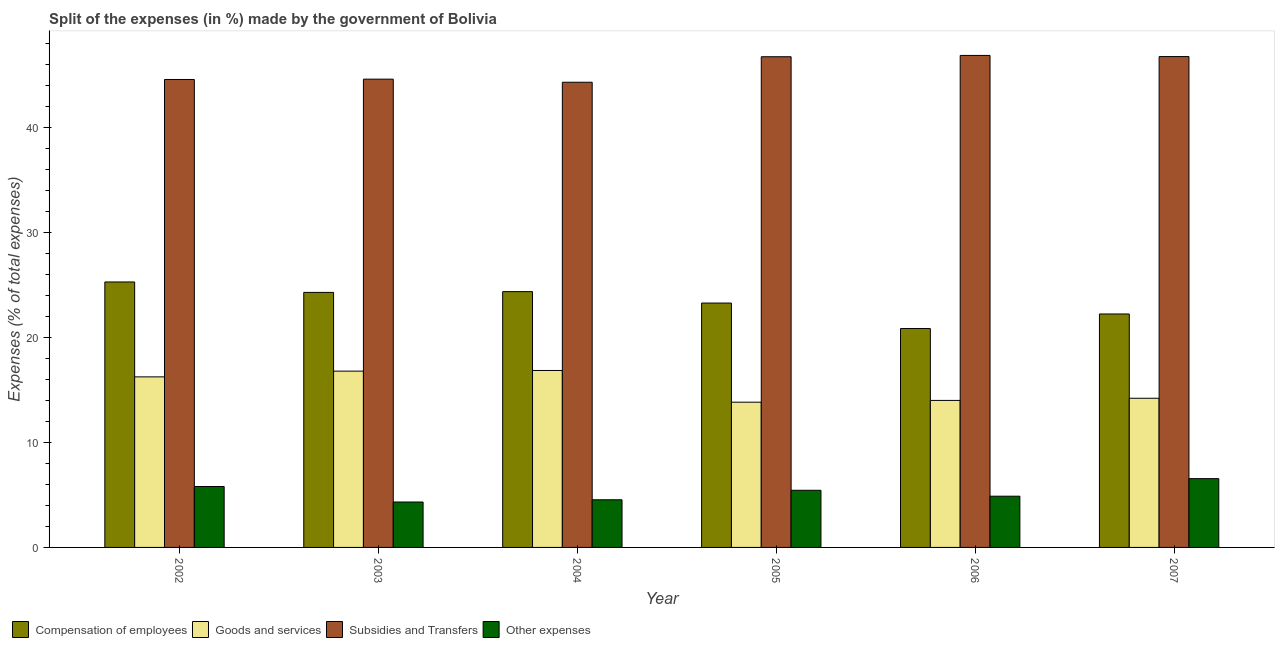How many groups of bars are there?
Ensure brevity in your answer.  6. Are the number of bars per tick equal to the number of legend labels?
Offer a terse response. Yes. In how many cases, is the number of bars for a given year not equal to the number of legend labels?
Your response must be concise. 0. What is the percentage of amount spent on compensation of employees in 2007?
Offer a very short reply. 22.22. Across all years, what is the maximum percentage of amount spent on other expenses?
Provide a short and direct response. 6.55. Across all years, what is the minimum percentage of amount spent on subsidies?
Your response must be concise. 44.27. In which year was the percentage of amount spent on goods and services maximum?
Offer a very short reply. 2004. What is the total percentage of amount spent on other expenses in the graph?
Your answer should be compact. 31.51. What is the difference between the percentage of amount spent on subsidies in 2002 and that in 2007?
Ensure brevity in your answer.  -2.18. What is the difference between the percentage of amount spent on goods and services in 2007 and the percentage of amount spent on subsidies in 2003?
Give a very brief answer. -2.58. What is the average percentage of amount spent on other expenses per year?
Make the answer very short. 5.25. What is the ratio of the percentage of amount spent on other expenses in 2002 to that in 2004?
Offer a terse response. 1.28. Is the difference between the percentage of amount spent on subsidies in 2005 and 2007 greater than the difference between the percentage of amount spent on other expenses in 2005 and 2007?
Your answer should be compact. No. What is the difference between the highest and the second highest percentage of amount spent on compensation of employees?
Ensure brevity in your answer.  0.92. What is the difference between the highest and the lowest percentage of amount spent on goods and services?
Provide a succinct answer. 3.02. Is the sum of the percentage of amount spent on subsidies in 2003 and 2004 greater than the maximum percentage of amount spent on goods and services across all years?
Provide a short and direct response. Yes. Is it the case that in every year, the sum of the percentage of amount spent on other expenses and percentage of amount spent on goods and services is greater than the sum of percentage of amount spent on compensation of employees and percentage of amount spent on subsidies?
Offer a very short reply. No. What does the 3rd bar from the left in 2003 represents?
Ensure brevity in your answer.  Subsidies and Transfers. What does the 2nd bar from the right in 2006 represents?
Make the answer very short. Subsidies and Transfers. Is it the case that in every year, the sum of the percentage of amount spent on compensation of employees and percentage of amount spent on goods and services is greater than the percentage of amount spent on subsidies?
Offer a very short reply. No. How many bars are there?
Keep it short and to the point. 24. Are all the bars in the graph horizontal?
Offer a very short reply. No. Are the values on the major ticks of Y-axis written in scientific E-notation?
Your answer should be very brief. No. Does the graph contain any zero values?
Your response must be concise. No. How many legend labels are there?
Your answer should be compact. 4. What is the title of the graph?
Your answer should be compact. Split of the expenses (in %) made by the government of Bolivia. Does "Oil" appear as one of the legend labels in the graph?
Your answer should be compact. No. What is the label or title of the Y-axis?
Make the answer very short. Expenses (% of total expenses). What is the Expenses (% of total expenses) of Compensation of employees in 2002?
Provide a succinct answer. 25.26. What is the Expenses (% of total expenses) of Goods and services in 2002?
Offer a very short reply. 16.23. What is the Expenses (% of total expenses) of Subsidies and Transfers in 2002?
Offer a very short reply. 44.53. What is the Expenses (% of total expenses) of Other expenses in 2002?
Make the answer very short. 5.8. What is the Expenses (% of total expenses) of Compensation of employees in 2003?
Offer a very short reply. 24.27. What is the Expenses (% of total expenses) of Goods and services in 2003?
Offer a very short reply. 16.78. What is the Expenses (% of total expenses) of Subsidies and Transfers in 2003?
Give a very brief answer. 44.56. What is the Expenses (% of total expenses) in Other expenses in 2003?
Your answer should be compact. 4.32. What is the Expenses (% of total expenses) in Compensation of employees in 2004?
Your answer should be very brief. 24.34. What is the Expenses (% of total expenses) of Goods and services in 2004?
Provide a short and direct response. 16.84. What is the Expenses (% of total expenses) of Subsidies and Transfers in 2004?
Provide a short and direct response. 44.27. What is the Expenses (% of total expenses) of Other expenses in 2004?
Ensure brevity in your answer.  4.53. What is the Expenses (% of total expenses) of Compensation of employees in 2005?
Offer a terse response. 23.26. What is the Expenses (% of total expenses) in Goods and services in 2005?
Your response must be concise. 13.82. What is the Expenses (% of total expenses) in Subsidies and Transfers in 2005?
Ensure brevity in your answer.  46.7. What is the Expenses (% of total expenses) of Other expenses in 2005?
Keep it short and to the point. 5.44. What is the Expenses (% of total expenses) in Compensation of employees in 2006?
Provide a succinct answer. 20.83. What is the Expenses (% of total expenses) of Goods and services in 2006?
Your response must be concise. 13.99. What is the Expenses (% of total expenses) in Subsidies and Transfers in 2006?
Offer a terse response. 46.82. What is the Expenses (% of total expenses) of Other expenses in 2006?
Give a very brief answer. 4.87. What is the Expenses (% of total expenses) of Compensation of employees in 2007?
Your response must be concise. 22.22. What is the Expenses (% of total expenses) in Goods and services in 2007?
Ensure brevity in your answer.  14.2. What is the Expenses (% of total expenses) in Subsidies and Transfers in 2007?
Give a very brief answer. 46.71. What is the Expenses (% of total expenses) in Other expenses in 2007?
Offer a very short reply. 6.55. Across all years, what is the maximum Expenses (% of total expenses) of Compensation of employees?
Give a very brief answer. 25.26. Across all years, what is the maximum Expenses (% of total expenses) of Goods and services?
Provide a succinct answer. 16.84. Across all years, what is the maximum Expenses (% of total expenses) in Subsidies and Transfers?
Keep it short and to the point. 46.82. Across all years, what is the maximum Expenses (% of total expenses) of Other expenses?
Your response must be concise. 6.55. Across all years, what is the minimum Expenses (% of total expenses) of Compensation of employees?
Offer a terse response. 20.83. Across all years, what is the minimum Expenses (% of total expenses) of Goods and services?
Your response must be concise. 13.82. Across all years, what is the minimum Expenses (% of total expenses) in Subsidies and Transfers?
Ensure brevity in your answer.  44.27. Across all years, what is the minimum Expenses (% of total expenses) of Other expenses?
Provide a short and direct response. 4.32. What is the total Expenses (% of total expenses) of Compensation of employees in the graph?
Provide a short and direct response. 140.18. What is the total Expenses (% of total expenses) in Goods and services in the graph?
Offer a terse response. 91.86. What is the total Expenses (% of total expenses) of Subsidies and Transfers in the graph?
Provide a short and direct response. 273.59. What is the total Expenses (% of total expenses) in Other expenses in the graph?
Provide a short and direct response. 31.51. What is the difference between the Expenses (% of total expenses) in Compensation of employees in 2002 and that in 2003?
Your answer should be compact. 0.99. What is the difference between the Expenses (% of total expenses) in Goods and services in 2002 and that in 2003?
Your response must be concise. -0.55. What is the difference between the Expenses (% of total expenses) in Subsidies and Transfers in 2002 and that in 2003?
Keep it short and to the point. -0.03. What is the difference between the Expenses (% of total expenses) of Other expenses in 2002 and that in 2003?
Your response must be concise. 1.47. What is the difference between the Expenses (% of total expenses) of Compensation of employees in 2002 and that in 2004?
Offer a terse response. 0.92. What is the difference between the Expenses (% of total expenses) of Goods and services in 2002 and that in 2004?
Ensure brevity in your answer.  -0.61. What is the difference between the Expenses (% of total expenses) of Subsidies and Transfers in 2002 and that in 2004?
Offer a very short reply. 0.26. What is the difference between the Expenses (% of total expenses) in Other expenses in 2002 and that in 2004?
Your answer should be compact. 1.26. What is the difference between the Expenses (% of total expenses) of Compensation of employees in 2002 and that in 2005?
Give a very brief answer. 2.01. What is the difference between the Expenses (% of total expenses) in Goods and services in 2002 and that in 2005?
Offer a terse response. 2.41. What is the difference between the Expenses (% of total expenses) of Subsidies and Transfers in 2002 and that in 2005?
Ensure brevity in your answer.  -2.16. What is the difference between the Expenses (% of total expenses) of Other expenses in 2002 and that in 2005?
Your answer should be very brief. 0.36. What is the difference between the Expenses (% of total expenses) in Compensation of employees in 2002 and that in 2006?
Offer a terse response. 4.43. What is the difference between the Expenses (% of total expenses) in Goods and services in 2002 and that in 2006?
Make the answer very short. 2.24. What is the difference between the Expenses (% of total expenses) of Subsidies and Transfers in 2002 and that in 2006?
Your answer should be very brief. -2.29. What is the difference between the Expenses (% of total expenses) of Other expenses in 2002 and that in 2006?
Offer a terse response. 0.92. What is the difference between the Expenses (% of total expenses) of Compensation of employees in 2002 and that in 2007?
Offer a very short reply. 3.05. What is the difference between the Expenses (% of total expenses) in Goods and services in 2002 and that in 2007?
Your answer should be very brief. 2.04. What is the difference between the Expenses (% of total expenses) of Subsidies and Transfers in 2002 and that in 2007?
Give a very brief answer. -2.18. What is the difference between the Expenses (% of total expenses) in Other expenses in 2002 and that in 2007?
Your answer should be very brief. -0.75. What is the difference between the Expenses (% of total expenses) in Compensation of employees in 2003 and that in 2004?
Your answer should be compact. -0.07. What is the difference between the Expenses (% of total expenses) of Goods and services in 2003 and that in 2004?
Your answer should be compact. -0.06. What is the difference between the Expenses (% of total expenses) in Subsidies and Transfers in 2003 and that in 2004?
Give a very brief answer. 0.29. What is the difference between the Expenses (% of total expenses) in Other expenses in 2003 and that in 2004?
Ensure brevity in your answer.  -0.21. What is the difference between the Expenses (% of total expenses) in Compensation of employees in 2003 and that in 2005?
Ensure brevity in your answer.  1.01. What is the difference between the Expenses (% of total expenses) of Goods and services in 2003 and that in 2005?
Provide a succinct answer. 2.96. What is the difference between the Expenses (% of total expenses) of Subsidies and Transfers in 2003 and that in 2005?
Your response must be concise. -2.13. What is the difference between the Expenses (% of total expenses) of Other expenses in 2003 and that in 2005?
Give a very brief answer. -1.11. What is the difference between the Expenses (% of total expenses) of Compensation of employees in 2003 and that in 2006?
Your answer should be very brief. 3.44. What is the difference between the Expenses (% of total expenses) in Goods and services in 2003 and that in 2006?
Keep it short and to the point. 2.79. What is the difference between the Expenses (% of total expenses) of Subsidies and Transfers in 2003 and that in 2006?
Your response must be concise. -2.26. What is the difference between the Expenses (% of total expenses) of Other expenses in 2003 and that in 2006?
Offer a very short reply. -0.55. What is the difference between the Expenses (% of total expenses) in Compensation of employees in 2003 and that in 2007?
Give a very brief answer. 2.05. What is the difference between the Expenses (% of total expenses) in Goods and services in 2003 and that in 2007?
Make the answer very short. 2.58. What is the difference between the Expenses (% of total expenses) of Subsidies and Transfers in 2003 and that in 2007?
Your response must be concise. -2.15. What is the difference between the Expenses (% of total expenses) of Other expenses in 2003 and that in 2007?
Your answer should be very brief. -2.22. What is the difference between the Expenses (% of total expenses) of Compensation of employees in 2004 and that in 2005?
Offer a very short reply. 1.09. What is the difference between the Expenses (% of total expenses) in Goods and services in 2004 and that in 2005?
Provide a short and direct response. 3.02. What is the difference between the Expenses (% of total expenses) of Subsidies and Transfers in 2004 and that in 2005?
Provide a short and direct response. -2.43. What is the difference between the Expenses (% of total expenses) of Other expenses in 2004 and that in 2005?
Ensure brevity in your answer.  -0.9. What is the difference between the Expenses (% of total expenses) of Compensation of employees in 2004 and that in 2006?
Offer a terse response. 3.51. What is the difference between the Expenses (% of total expenses) of Goods and services in 2004 and that in 2006?
Provide a succinct answer. 2.85. What is the difference between the Expenses (% of total expenses) of Subsidies and Transfers in 2004 and that in 2006?
Offer a very short reply. -2.55. What is the difference between the Expenses (% of total expenses) in Other expenses in 2004 and that in 2006?
Offer a terse response. -0.34. What is the difference between the Expenses (% of total expenses) in Compensation of employees in 2004 and that in 2007?
Provide a succinct answer. 2.13. What is the difference between the Expenses (% of total expenses) of Goods and services in 2004 and that in 2007?
Your response must be concise. 2.64. What is the difference between the Expenses (% of total expenses) in Subsidies and Transfers in 2004 and that in 2007?
Offer a terse response. -2.44. What is the difference between the Expenses (% of total expenses) in Other expenses in 2004 and that in 2007?
Keep it short and to the point. -2.01. What is the difference between the Expenses (% of total expenses) of Compensation of employees in 2005 and that in 2006?
Offer a very short reply. 2.42. What is the difference between the Expenses (% of total expenses) of Goods and services in 2005 and that in 2006?
Give a very brief answer. -0.17. What is the difference between the Expenses (% of total expenses) of Subsidies and Transfers in 2005 and that in 2006?
Offer a terse response. -0.12. What is the difference between the Expenses (% of total expenses) of Other expenses in 2005 and that in 2006?
Offer a terse response. 0.56. What is the difference between the Expenses (% of total expenses) of Compensation of employees in 2005 and that in 2007?
Your response must be concise. 1.04. What is the difference between the Expenses (% of total expenses) in Goods and services in 2005 and that in 2007?
Ensure brevity in your answer.  -0.37. What is the difference between the Expenses (% of total expenses) in Subsidies and Transfers in 2005 and that in 2007?
Your answer should be very brief. -0.02. What is the difference between the Expenses (% of total expenses) in Other expenses in 2005 and that in 2007?
Keep it short and to the point. -1.11. What is the difference between the Expenses (% of total expenses) in Compensation of employees in 2006 and that in 2007?
Keep it short and to the point. -1.39. What is the difference between the Expenses (% of total expenses) in Goods and services in 2006 and that in 2007?
Give a very brief answer. -0.21. What is the difference between the Expenses (% of total expenses) of Subsidies and Transfers in 2006 and that in 2007?
Offer a very short reply. 0.11. What is the difference between the Expenses (% of total expenses) of Other expenses in 2006 and that in 2007?
Keep it short and to the point. -1.67. What is the difference between the Expenses (% of total expenses) of Compensation of employees in 2002 and the Expenses (% of total expenses) of Goods and services in 2003?
Provide a succinct answer. 8.49. What is the difference between the Expenses (% of total expenses) of Compensation of employees in 2002 and the Expenses (% of total expenses) of Subsidies and Transfers in 2003?
Keep it short and to the point. -19.3. What is the difference between the Expenses (% of total expenses) of Compensation of employees in 2002 and the Expenses (% of total expenses) of Other expenses in 2003?
Offer a very short reply. 20.94. What is the difference between the Expenses (% of total expenses) in Goods and services in 2002 and the Expenses (% of total expenses) in Subsidies and Transfers in 2003?
Your answer should be compact. -28.33. What is the difference between the Expenses (% of total expenses) of Goods and services in 2002 and the Expenses (% of total expenses) of Other expenses in 2003?
Keep it short and to the point. 11.91. What is the difference between the Expenses (% of total expenses) in Subsidies and Transfers in 2002 and the Expenses (% of total expenses) in Other expenses in 2003?
Your answer should be very brief. 40.21. What is the difference between the Expenses (% of total expenses) in Compensation of employees in 2002 and the Expenses (% of total expenses) in Goods and services in 2004?
Keep it short and to the point. 8.42. What is the difference between the Expenses (% of total expenses) of Compensation of employees in 2002 and the Expenses (% of total expenses) of Subsidies and Transfers in 2004?
Your answer should be very brief. -19.01. What is the difference between the Expenses (% of total expenses) in Compensation of employees in 2002 and the Expenses (% of total expenses) in Other expenses in 2004?
Provide a short and direct response. 20.73. What is the difference between the Expenses (% of total expenses) of Goods and services in 2002 and the Expenses (% of total expenses) of Subsidies and Transfers in 2004?
Your answer should be very brief. -28.04. What is the difference between the Expenses (% of total expenses) in Goods and services in 2002 and the Expenses (% of total expenses) in Other expenses in 2004?
Give a very brief answer. 11.7. What is the difference between the Expenses (% of total expenses) in Subsidies and Transfers in 2002 and the Expenses (% of total expenses) in Other expenses in 2004?
Offer a very short reply. 40. What is the difference between the Expenses (% of total expenses) of Compensation of employees in 2002 and the Expenses (% of total expenses) of Goods and services in 2005?
Ensure brevity in your answer.  11.44. What is the difference between the Expenses (% of total expenses) of Compensation of employees in 2002 and the Expenses (% of total expenses) of Subsidies and Transfers in 2005?
Offer a terse response. -21.43. What is the difference between the Expenses (% of total expenses) in Compensation of employees in 2002 and the Expenses (% of total expenses) in Other expenses in 2005?
Your answer should be very brief. 19.83. What is the difference between the Expenses (% of total expenses) of Goods and services in 2002 and the Expenses (% of total expenses) of Subsidies and Transfers in 2005?
Ensure brevity in your answer.  -30.47. What is the difference between the Expenses (% of total expenses) in Goods and services in 2002 and the Expenses (% of total expenses) in Other expenses in 2005?
Your response must be concise. 10.79. What is the difference between the Expenses (% of total expenses) in Subsidies and Transfers in 2002 and the Expenses (% of total expenses) in Other expenses in 2005?
Your response must be concise. 39.1. What is the difference between the Expenses (% of total expenses) in Compensation of employees in 2002 and the Expenses (% of total expenses) in Goods and services in 2006?
Your answer should be compact. 11.27. What is the difference between the Expenses (% of total expenses) in Compensation of employees in 2002 and the Expenses (% of total expenses) in Subsidies and Transfers in 2006?
Keep it short and to the point. -21.56. What is the difference between the Expenses (% of total expenses) in Compensation of employees in 2002 and the Expenses (% of total expenses) in Other expenses in 2006?
Ensure brevity in your answer.  20.39. What is the difference between the Expenses (% of total expenses) in Goods and services in 2002 and the Expenses (% of total expenses) in Subsidies and Transfers in 2006?
Your answer should be very brief. -30.59. What is the difference between the Expenses (% of total expenses) in Goods and services in 2002 and the Expenses (% of total expenses) in Other expenses in 2006?
Ensure brevity in your answer.  11.36. What is the difference between the Expenses (% of total expenses) of Subsidies and Transfers in 2002 and the Expenses (% of total expenses) of Other expenses in 2006?
Offer a very short reply. 39.66. What is the difference between the Expenses (% of total expenses) in Compensation of employees in 2002 and the Expenses (% of total expenses) in Goods and services in 2007?
Ensure brevity in your answer.  11.07. What is the difference between the Expenses (% of total expenses) of Compensation of employees in 2002 and the Expenses (% of total expenses) of Subsidies and Transfers in 2007?
Ensure brevity in your answer.  -21.45. What is the difference between the Expenses (% of total expenses) in Compensation of employees in 2002 and the Expenses (% of total expenses) in Other expenses in 2007?
Ensure brevity in your answer.  18.72. What is the difference between the Expenses (% of total expenses) of Goods and services in 2002 and the Expenses (% of total expenses) of Subsidies and Transfers in 2007?
Provide a succinct answer. -30.48. What is the difference between the Expenses (% of total expenses) in Goods and services in 2002 and the Expenses (% of total expenses) in Other expenses in 2007?
Offer a terse response. 9.68. What is the difference between the Expenses (% of total expenses) of Subsidies and Transfers in 2002 and the Expenses (% of total expenses) of Other expenses in 2007?
Your answer should be compact. 37.99. What is the difference between the Expenses (% of total expenses) of Compensation of employees in 2003 and the Expenses (% of total expenses) of Goods and services in 2004?
Offer a terse response. 7.43. What is the difference between the Expenses (% of total expenses) in Compensation of employees in 2003 and the Expenses (% of total expenses) in Subsidies and Transfers in 2004?
Offer a very short reply. -20. What is the difference between the Expenses (% of total expenses) of Compensation of employees in 2003 and the Expenses (% of total expenses) of Other expenses in 2004?
Offer a very short reply. 19.74. What is the difference between the Expenses (% of total expenses) of Goods and services in 2003 and the Expenses (% of total expenses) of Subsidies and Transfers in 2004?
Your response must be concise. -27.49. What is the difference between the Expenses (% of total expenses) of Goods and services in 2003 and the Expenses (% of total expenses) of Other expenses in 2004?
Make the answer very short. 12.24. What is the difference between the Expenses (% of total expenses) in Subsidies and Transfers in 2003 and the Expenses (% of total expenses) in Other expenses in 2004?
Your response must be concise. 40.03. What is the difference between the Expenses (% of total expenses) of Compensation of employees in 2003 and the Expenses (% of total expenses) of Goods and services in 2005?
Provide a succinct answer. 10.45. What is the difference between the Expenses (% of total expenses) in Compensation of employees in 2003 and the Expenses (% of total expenses) in Subsidies and Transfers in 2005?
Provide a short and direct response. -22.43. What is the difference between the Expenses (% of total expenses) in Compensation of employees in 2003 and the Expenses (% of total expenses) in Other expenses in 2005?
Keep it short and to the point. 18.83. What is the difference between the Expenses (% of total expenses) in Goods and services in 2003 and the Expenses (% of total expenses) in Subsidies and Transfers in 2005?
Your answer should be very brief. -29.92. What is the difference between the Expenses (% of total expenses) of Goods and services in 2003 and the Expenses (% of total expenses) of Other expenses in 2005?
Your answer should be compact. 11.34. What is the difference between the Expenses (% of total expenses) of Subsidies and Transfers in 2003 and the Expenses (% of total expenses) of Other expenses in 2005?
Give a very brief answer. 39.13. What is the difference between the Expenses (% of total expenses) of Compensation of employees in 2003 and the Expenses (% of total expenses) of Goods and services in 2006?
Make the answer very short. 10.28. What is the difference between the Expenses (% of total expenses) in Compensation of employees in 2003 and the Expenses (% of total expenses) in Subsidies and Transfers in 2006?
Your answer should be very brief. -22.55. What is the difference between the Expenses (% of total expenses) in Compensation of employees in 2003 and the Expenses (% of total expenses) in Other expenses in 2006?
Give a very brief answer. 19.4. What is the difference between the Expenses (% of total expenses) of Goods and services in 2003 and the Expenses (% of total expenses) of Subsidies and Transfers in 2006?
Your answer should be compact. -30.04. What is the difference between the Expenses (% of total expenses) in Goods and services in 2003 and the Expenses (% of total expenses) in Other expenses in 2006?
Your response must be concise. 11.9. What is the difference between the Expenses (% of total expenses) in Subsidies and Transfers in 2003 and the Expenses (% of total expenses) in Other expenses in 2006?
Offer a very short reply. 39.69. What is the difference between the Expenses (% of total expenses) of Compensation of employees in 2003 and the Expenses (% of total expenses) of Goods and services in 2007?
Offer a very short reply. 10.07. What is the difference between the Expenses (% of total expenses) in Compensation of employees in 2003 and the Expenses (% of total expenses) in Subsidies and Transfers in 2007?
Your response must be concise. -22.44. What is the difference between the Expenses (% of total expenses) in Compensation of employees in 2003 and the Expenses (% of total expenses) in Other expenses in 2007?
Provide a short and direct response. 17.72. What is the difference between the Expenses (% of total expenses) in Goods and services in 2003 and the Expenses (% of total expenses) in Subsidies and Transfers in 2007?
Offer a very short reply. -29.93. What is the difference between the Expenses (% of total expenses) of Goods and services in 2003 and the Expenses (% of total expenses) of Other expenses in 2007?
Your response must be concise. 10.23. What is the difference between the Expenses (% of total expenses) of Subsidies and Transfers in 2003 and the Expenses (% of total expenses) of Other expenses in 2007?
Provide a succinct answer. 38.02. What is the difference between the Expenses (% of total expenses) in Compensation of employees in 2004 and the Expenses (% of total expenses) in Goods and services in 2005?
Provide a short and direct response. 10.52. What is the difference between the Expenses (% of total expenses) in Compensation of employees in 2004 and the Expenses (% of total expenses) in Subsidies and Transfers in 2005?
Offer a terse response. -22.35. What is the difference between the Expenses (% of total expenses) of Compensation of employees in 2004 and the Expenses (% of total expenses) of Other expenses in 2005?
Provide a short and direct response. 18.91. What is the difference between the Expenses (% of total expenses) of Goods and services in 2004 and the Expenses (% of total expenses) of Subsidies and Transfers in 2005?
Keep it short and to the point. -29.86. What is the difference between the Expenses (% of total expenses) of Goods and services in 2004 and the Expenses (% of total expenses) of Other expenses in 2005?
Ensure brevity in your answer.  11.4. What is the difference between the Expenses (% of total expenses) of Subsidies and Transfers in 2004 and the Expenses (% of total expenses) of Other expenses in 2005?
Ensure brevity in your answer.  38.83. What is the difference between the Expenses (% of total expenses) of Compensation of employees in 2004 and the Expenses (% of total expenses) of Goods and services in 2006?
Offer a terse response. 10.35. What is the difference between the Expenses (% of total expenses) in Compensation of employees in 2004 and the Expenses (% of total expenses) in Subsidies and Transfers in 2006?
Keep it short and to the point. -22.48. What is the difference between the Expenses (% of total expenses) in Compensation of employees in 2004 and the Expenses (% of total expenses) in Other expenses in 2006?
Give a very brief answer. 19.47. What is the difference between the Expenses (% of total expenses) of Goods and services in 2004 and the Expenses (% of total expenses) of Subsidies and Transfers in 2006?
Keep it short and to the point. -29.98. What is the difference between the Expenses (% of total expenses) in Goods and services in 2004 and the Expenses (% of total expenses) in Other expenses in 2006?
Offer a terse response. 11.96. What is the difference between the Expenses (% of total expenses) of Subsidies and Transfers in 2004 and the Expenses (% of total expenses) of Other expenses in 2006?
Offer a very short reply. 39.39. What is the difference between the Expenses (% of total expenses) in Compensation of employees in 2004 and the Expenses (% of total expenses) in Goods and services in 2007?
Give a very brief answer. 10.15. What is the difference between the Expenses (% of total expenses) in Compensation of employees in 2004 and the Expenses (% of total expenses) in Subsidies and Transfers in 2007?
Give a very brief answer. -22.37. What is the difference between the Expenses (% of total expenses) in Compensation of employees in 2004 and the Expenses (% of total expenses) in Other expenses in 2007?
Make the answer very short. 17.8. What is the difference between the Expenses (% of total expenses) of Goods and services in 2004 and the Expenses (% of total expenses) of Subsidies and Transfers in 2007?
Provide a short and direct response. -29.87. What is the difference between the Expenses (% of total expenses) in Goods and services in 2004 and the Expenses (% of total expenses) in Other expenses in 2007?
Provide a succinct answer. 10.29. What is the difference between the Expenses (% of total expenses) of Subsidies and Transfers in 2004 and the Expenses (% of total expenses) of Other expenses in 2007?
Offer a terse response. 37.72. What is the difference between the Expenses (% of total expenses) of Compensation of employees in 2005 and the Expenses (% of total expenses) of Goods and services in 2006?
Offer a terse response. 9.26. What is the difference between the Expenses (% of total expenses) in Compensation of employees in 2005 and the Expenses (% of total expenses) in Subsidies and Transfers in 2006?
Your response must be concise. -23.57. What is the difference between the Expenses (% of total expenses) in Compensation of employees in 2005 and the Expenses (% of total expenses) in Other expenses in 2006?
Provide a short and direct response. 18.38. What is the difference between the Expenses (% of total expenses) in Goods and services in 2005 and the Expenses (% of total expenses) in Subsidies and Transfers in 2006?
Provide a short and direct response. -33. What is the difference between the Expenses (% of total expenses) in Goods and services in 2005 and the Expenses (% of total expenses) in Other expenses in 2006?
Keep it short and to the point. 8.95. What is the difference between the Expenses (% of total expenses) of Subsidies and Transfers in 2005 and the Expenses (% of total expenses) of Other expenses in 2006?
Make the answer very short. 41.82. What is the difference between the Expenses (% of total expenses) of Compensation of employees in 2005 and the Expenses (% of total expenses) of Goods and services in 2007?
Provide a short and direct response. 9.06. What is the difference between the Expenses (% of total expenses) of Compensation of employees in 2005 and the Expenses (% of total expenses) of Subsidies and Transfers in 2007?
Provide a short and direct response. -23.46. What is the difference between the Expenses (% of total expenses) in Compensation of employees in 2005 and the Expenses (% of total expenses) in Other expenses in 2007?
Keep it short and to the point. 16.71. What is the difference between the Expenses (% of total expenses) of Goods and services in 2005 and the Expenses (% of total expenses) of Subsidies and Transfers in 2007?
Keep it short and to the point. -32.89. What is the difference between the Expenses (% of total expenses) in Goods and services in 2005 and the Expenses (% of total expenses) in Other expenses in 2007?
Provide a succinct answer. 7.28. What is the difference between the Expenses (% of total expenses) of Subsidies and Transfers in 2005 and the Expenses (% of total expenses) of Other expenses in 2007?
Your response must be concise. 40.15. What is the difference between the Expenses (% of total expenses) of Compensation of employees in 2006 and the Expenses (% of total expenses) of Goods and services in 2007?
Your response must be concise. 6.63. What is the difference between the Expenses (% of total expenses) in Compensation of employees in 2006 and the Expenses (% of total expenses) in Subsidies and Transfers in 2007?
Make the answer very short. -25.88. What is the difference between the Expenses (% of total expenses) of Compensation of employees in 2006 and the Expenses (% of total expenses) of Other expenses in 2007?
Your answer should be very brief. 14.28. What is the difference between the Expenses (% of total expenses) of Goods and services in 2006 and the Expenses (% of total expenses) of Subsidies and Transfers in 2007?
Your response must be concise. -32.72. What is the difference between the Expenses (% of total expenses) in Goods and services in 2006 and the Expenses (% of total expenses) in Other expenses in 2007?
Provide a short and direct response. 7.44. What is the difference between the Expenses (% of total expenses) in Subsidies and Transfers in 2006 and the Expenses (% of total expenses) in Other expenses in 2007?
Your response must be concise. 40.27. What is the average Expenses (% of total expenses) in Compensation of employees per year?
Provide a short and direct response. 23.36. What is the average Expenses (% of total expenses) of Goods and services per year?
Offer a very short reply. 15.31. What is the average Expenses (% of total expenses) of Subsidies and Transfers per year?
Keep it short and to the point. 45.6. What is the average Expenses (% of total expenses) of Other expenses per year?
Provide a succinct answer. 5.25. In the year 2002, what is the difference between the Expenses (% of total expenses) of Compensation of employees and Expenses (% of total expenses) of Goods and services?
Ensure brevity in your answer.  9.03. In the year 2002, what is the difference between the Expenses (% of total expenses) in Compensation of employees and Expenses (% of total expenses) in Subsidies and Transfers?
Offer a terse response. -19.27. In the year 2002, what is the difference between the Expenses (% of total expenses) in Compensation of employees and Expenses (% of total expenses) in Other expenses?
Keep it short and to the point. 19.47. In the year 2002, what is the difference between the Expenses (% of total expenses) of Goods and services and Expenses (% of total expenses) of Subsidies and Transfers?
Keep it short and to the point. -28.3. In the year 2002, what is the difference between the Expenses (% of total expenses) in Goods and services and Expenses (% of total expenses) in Other expenses?
Your response must be concise. 10.43. In the year 2002, what is the difference between the Expenses (% of total expenses) in Subsidies and Transfers and Expenses (% of total expenses) in Other expenses?
Keep it short and to the point. 38.74. In the year 2003, what is the difference between the Expenses (% of total expenses) of Compensation of employees and Expenses (% of total expenses) of Goods and services?
Provide a succinct answer. 7.49. In the year 2003, what is the difference between the Expenses (% of total expenses) of Compensation of employees and Expenses (% of total expenses) of Subsidies and Transfers?
Offer a very short reply. -20.29. In the year 2003, what is the difference between the Expenses (% of total expenses) in Compensation of employees and Expenses (% of total expenses) in Other expenses?
Offer a terse response. 19.95. In the year 2003, what is the difference between the Expenses (% of total expenses) in Goods and services and Expenses (% of total expenses) in Subsidies and Transfers?
Your answer should be very brief. -27.79. In the year 2003, what is the difference between the Expenses (% of total expenses) of Goods and services and Expenses (% of total expenses) of Other expenses?
Provide a succinct answer. 12.45. In the year 2003, what is the difference between the Expenses (% of total expenses) of Subsidies and Transfers and Expenses (% of total expenses) of Other expenses?
Ensure brevity in your answer.  40.24. In the year 2004, what is the difference between the Expenses (% of total expenses) of Compensation of employees and Expenses (% of total expenses) of Goods and services?
Provide a short and direct response. 7.5. In the year 2004, what is the difference between the Expenses (% of total expenses) in Compensation of employees and Expenses (% of total expenses) in Subsidies and Transfers?
Provide a short and direct response. -19.93. In the year 2004, what is the difference between the Expenses (% of total expenses) in Compensation of employees and Expenses (% of total expenses) in Other expenses?
Your answer should be compact. 19.81. In the year 2004, what is the difference between the Expenses (% of total expenses) in Goods and services and Expenses (% of total expenses) in Subsidies and Transfers?
Your answer should be compact. -27.43. In the year 2004, what is the difference between the Expenses (% of total expenses) in Goods and services and Expenses (% of total expenses) in Other expenses?
Your answer should be very brief. 12.3. In the year 2004, what is the difference between the Expenses (% of total expenses) of Subsidies and Transfers and Expenses (% of total expenses) of Other expenses?
Offer a very short reply. 39.73. In the year 2005, what is the difference between the Expenses (% of total expenses) in Compensation of employees and Expenses (% of total expenses) in Goods and services?
Your answer should be compact. 9.43. In the year 2005, what is the difference between the Expenses (% of total expenses) of Compensation of employees and Expenses (% of total expenses) of Subsidies and Transfers?
Keep it short and to the point. -23.44. In the year 2005, what is the difference between the Expenses (% of total expenses) of Compensation of employees and Expenses (% of total expenses) of Other expenses?
Give a very brief answer. 17.82. In the year 2005, what is the difference between the Expenses (% of total expenses) in Goods and services and Expenses (% of total expenses) in Subsidies and Transfers?
Ensure brevity in your answer.  -32.87. In the year 2005, what is the difference between the Expenses (% of total expenses) of Goods and services and Expenses (% of total expenses) of Other expenses?
Offer a terse response. 8.39. In the year 2005, what is the difference between the Expenses (% of total expenses) of Subsidies and Transfers and Expenses (% of total expenses) of Other expenses?
Provide a succinct answer. 41.26. In the year 2006, what is the difference between the Expenses (% of total expenses) of Compensation of employees and Expenses (% of total expenses) of Goods and services?
Your answer should be compact. 6.84. In the year 2006, what is the difference between the Expenses (% of total expenses) of Compensation of employees and Expenses (% of total expenses) of Subsidies and Transfers?
Keep it short and to the point. -25.99. In the year 2006, what is the difference between the Expenses (% of total expenses) in Compensation of employees and Expenses (% of total expenses) in Other expenses?
Provide a short and direct response. 15.96. In the year 2006, what is the difference between the Expenses (% of total expenses) of Goods and services and Expenses (% of total expenses) of Subsidies and Transfers?
Make the answer very short. -32.83. In the year 2006, what is the difference between the Expenses (% of total expenses) in Goods and services and Expenses (% of total expenses) in Other expenses?
Offer a very short reply. 9.12. In the year 2006, what is the difference between the Expenses (% of total expenses) in Subsidies and Transfers and Expenses (% of total expenses) in Other expenses?
Make the answer very short. 41.95. In the year 2007, what is the difference between the Expenses (% of total expenses) of Compensation of employees and Expenses (% of total expenses) of Goods and services?
Offer a very short reply. 8.02. In the year 2007, what is the difference between the Expenses (% of total expenses) in Compensation of employees and Expenses (% of total expenses) in Subsidies and Transfers?
Offer a terse response. -24.5. In the year 2007, what is the difference between the Expenses (% of total expenses) in Compensation of employees and Expenses (% of total expenses) in Other expenses?
Offer a terse response. 15.67. In the year 2007, what is the difference between the Expenses (% of total expenses) in Goods and services and Expenses (% of total expenses) in Subsidies and Transfers?
Your response must be concise. -32.52. In the year 2007, what is the difference between the Expenses (% of total expenses) in Goods and services and Expenses (% of total expenses) in Other expenses?
Offer a terse response. 7.65. In the year 2007, what is the difference between the Expenses (% of total expenses) in Subsidies and Transfers and Expenses (% of total expenses) in Other expenses?
Your answer should be very brief. 40.16. What is the ratio of the Expenses (% of total expenses) in Compensation of employees in 2002 to that in 2003?
Keep it short and to the point. 1.04. What is the ratio of the Expenses (% of total expenses) of Goods and services in 2002 to that in 2003?
Your answer should be very brief. 0.97. What is the ratio of the Expenses (% of total expenses) in Other expenses in 2002 to that in 2003?
Provide a short and direct response. 1.34. What is the ratio of the Expenses (% of total expenses) of Compensation of employees in 2002 to that in 2004?
Make the answer very short. 1.04. What is the ratio of the Expenses (% of total expenses) of Goods and services in 2002 to that in 2004?
Offer a very short reply. 0.96. What is the ratio of the Expenses (% of total expenses) of Subsidies and Transfers in 2002 to that in 2004?
Offer a very short reply. 1.01. What is the ratio of the Expenses (% of total expenses) of Other expenses in 2002 to that in 2004?
Offer a very short reply. 1.28. What is the ratio of the Expenses (% of total expenses) of Compensation of employees in 2002 to that in 2005?
Your answer should be very brief. 1.09. What is the ratio of the Expenses (% of total expenses) in Goods and services in 2002 to that in 2005?
Your response must be concise. 1.17. What is the ratio of the Expenses (% of total expenses) of Subsidies and Transfers in 2002 to that in 2005?
Ensure brevity in your answer.  0.95. What is the ratio of the Expenses (% of total expenses) of Other expenses in 2002 to that in 2005?
Provide a succinct answer. 1.07. What is the ratio of the Expenses (% of total expenses) in Compensation of employees in 2002 to that in 2006?
Your response must be concise. 1.21. What is the ratio of the Expenses (% of total expenses) of Goods and services in 2002 to that in 2006?
Make the answer very short. 1.16. What is the ratio of the Expenses (% of total expenses) in Subsidies and Transfers in 2002 to that in 2006?
Provide a succinct answer. 0.95. What is the ratio of the Expenses (% of total expenses) of Other expenses in 2002 to that in 2006?
Keep it short and to the point. 1.19. What is the ratio of the Expenses (% of total expenses) of Compensation of employees in 2002 to that in 2007?
Your answer should be very brief. 1.14. What is the ratio of the Expenses (% of total expenses) of Goods and services in 2002 to that in 2007?
Ensure brevity in your answer.  1.14. What is the ratio of the Expenses (% of total expenses) of Subsidies and Transfers in 2002 to that in 2007?
Provide a succinct answer. 0.95. What is the ratio of the Expenses (% of total expenses) in Other expenses in 2002 to that in 2007?
Offer a terse response. 0.89. What is the ratio of the Expenses (% of total expenses) of Compensation of employees in 2003 to that in 2004?
Give a very brief answer. 1. What is the ratio of the Expenses (% of total expenses) of Goods and services in 2003 to that in 2004?
Provide a short and direct response. 1. What is the ratio of the Expenses (% of total expenses) of Subsidies and Transfers in 2003 to that in 2004?
Offer a very short reply. 1.01. What is the ratio of the Expenses (% of total expenses) in Other expenses in 2003 to that in 2004?
Provide a succinct answer. 0.95. What is the ratio of the Expenses (% of total expenses) in Compensation of employees in 2003 to that in 2005?
Provide a short and direct response. 1.04. What is the ratio of the Expenses (% of total expenses) in Goods and services in 2003 to that in 2005?
Your answer should be very brief. 1.21. What is the ratio of the Expenses (% of total expenses) in Subsidies and Transfers in 2003 to that in 2005?
Make the answer very short. 0.95. What is the ratio of the Expenses (% of total expenses) in Other expenses in 2003 to that in 2005?
Offer a terse response. 0.8. What is the ratio of the Expenses (% of total expenses) of Compensation of employees in 2003 to that in 2006?
Your answer should be very brief. 1.17. What is the ratio of the Expenses (% of total expenses) in Goods and services in 2003 to that in 2006?
Ensure brevity in your answer.  1.2. What is the ratio of the Expenses (% of total expenses) in Subsidies and Transfers in 2003 to that in 2006?
Keep it short and to the point. 0.95. What is the ratio of the Expenses (% of total expenses) in Other expenses in 2003 to that in 2006?
Your answer should be compact. 0.89. What is the ratio of the Expenses (% of total expenses) in Compensation of employees in 2003 to that in 2007?
Your response must be concise. 1.09. What is the ratio of the Expenses (% of total expenses) of Goods and services in 2003 to that in 2007?
Your response must be concise. 1.18. What is the ratio of the Expenses (% of total expenses) of Subsidies and Transfers in 2003 to that in 2007?
Your answer should be compact. 0.95. What is the ratio of the Expenses (% of total expenses) of Other expenses in 2003 to that in 2007?
Offer a very short reply. 0.66. What is the ratio of the Expenses (% of total expenses) in Compensation of employees in 2004 to that in 2005?
Provide a short and direct response. 1.05. What is the ratio of the Expenses (% of total expenses) in Goods and services in 2004 to that in 2005?
Give a very brief answer. 1.22. What is the ratio of the Expenses (% of total expenses) of Subsidies and Transfers in 2004 to that in 2005?
Give a very brief answer. 0.95. What is the ratio of the Expenses (% of total expenses) of Other expenses in 2004 to that in 2005?
Your answer should be very brief. 0.83. What is the ratio of the Expenses (% of total expenses) in Compensation of employees in 2004 to that in 2006?
Provide a short and direct response. 1.17. What is the ratio of the Expenses (% of total expenses) of Goods and services in 2004 to that in 2006?
Make the answer very short. 1.2. What is the ratio of the Expenses (% of total expenses) in Subsidies and Transfers in 2004 to that in 2006?
Give a very brief answer. 0.95. What is the ratio of the Expenses (% of total expenses) in Other expenses in 2004 to that in 2006?
Make the answer very short. 0.93. What is the ratio of the Expenses (% of total expenses) of Compensation of employees in 2004 to that in 2007?
Offer a terse response. 1.1. What is the ratio of the Expenses (% of total expenses) of Goods and services in 2004 to that in 2007?
Give a very brief answer. 1.19. What is the ratio of the Expenses (% of total expenses) in Subsidies and Transfers in 2004 to that in 2007?
Provide a succinct answer. 0.95. What is the ratio of the Expenses (% of total expenses) in Other expenses in 2004 to that in 2007?
Your response must be concise. 0.69. What is the ratio of the Expenses (% of total expenses) in Compensation of employees in 2005 to that in 2006?
Keep it short and to the point. 1.12. What is the ratio of the Expenses (% of total expenses) of Goods and services in 2005 to that in 2006?
Provide a short and direct response. 0.99. What is the ratio of the Expenses (% of total expenses) in Subsidies and Transfers in 2005 to that in 2006?
Ensure brevity in your answer.  1. What is the ratio of the Expenses (% of total expenses) of Other expenses in 2005 to that in 2006?
Your answer should be very brief. 1.12. What is the ratio of the Expenses (% of total expenses) of Compensation of employees in 2005 to that in 2007?
Offer a very short reply. 1.05. What is the ratio of the Expenses (% of total expenses) in Goods and services in 2005 to that in 2007?
Provide a short and direct response. 0.97. What is the ratio of the Expenses (% of total expenses) of Other expenses in 2005 to that in 2007?
Ensure brevity in your answer.  0.83. What is the ratio of the Expenses (% of total expenses) of Compensation of employees in 2006 to that in 2007?
Your answer should be very brief. 0.94. What is the ratio of the Expenses (% of total expenses) in Goods and services in 2006 to that in 2007?
Provide a short and direct response. 0.99. What is the ratio of the Expenses (% of total expenses) in Subsidies and Transfers in 2006 to that in 2007?
Provide a succinct answer. 1. What is the ratio of the Expenses (% of total expenses) in Other expenses in 2006 to that in 2007?
Ensure brevity in your answer.  0.74. What is the difference between the highest and the second highest Expenses (% of total expenses) in Compensation of employees?
Give a very brief answer. 0.92. What is the difference between the highest and the second highest Expenses (% of total expenses) of Goods and services?
Your answer should be compact. 0.06. What is the difference between the highest and the second highest Expenses (% of total expenses) of Subsidies and Transfers?
Provide a short and direct response. 0.11. What is the difference between the highest and the second highest Expenses (% of total expenses) of Other expenses?
Your response must be concise. 0.75. What is the difference between the highest and the lowest Expenses (% of total expenses) in Compensation of employees?
Offer a very short reply. 4.43. What is the difference between the highest and the lowest Expenses (% of total expenses) in Goods and services?
Keep it short and to the point. 3.02. What is the difference between the highest and the lowest Expenses (% of total expenses) of Subsidies and Transfers?
Provide a short and direct response. 2.55. What is the difference between the highest and the lowest Expenses (% of total expenses) of Other expenses?
Give a very brief answer. 2.22. 